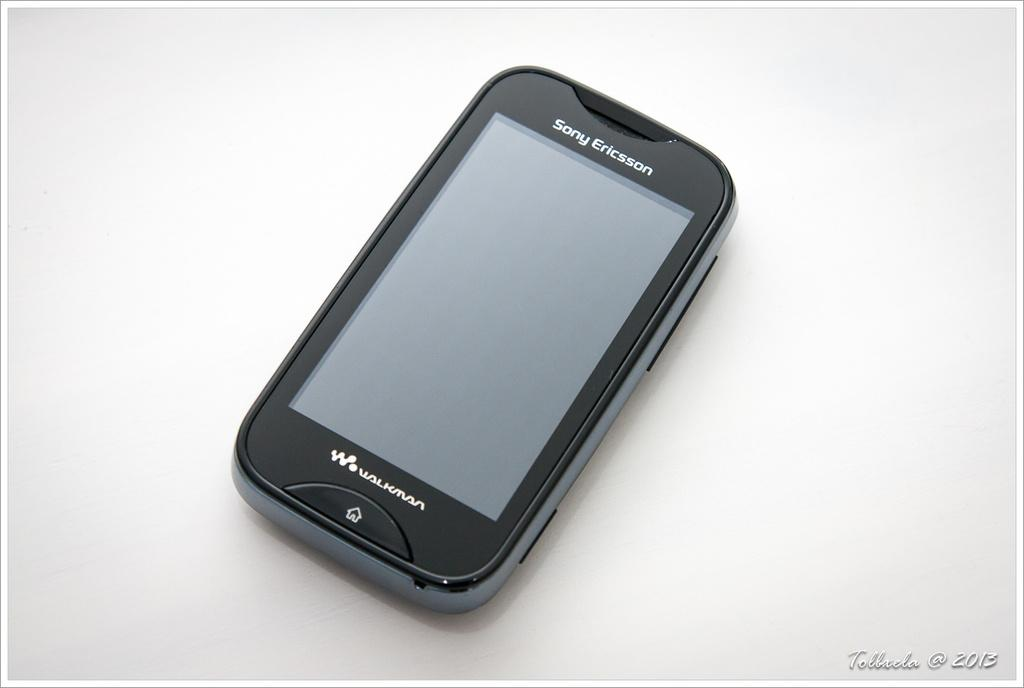<image>
Describe the image concisely. A black Sony Ericson Walkman portable music player with Tollada@2013 in the bottom right corner. 